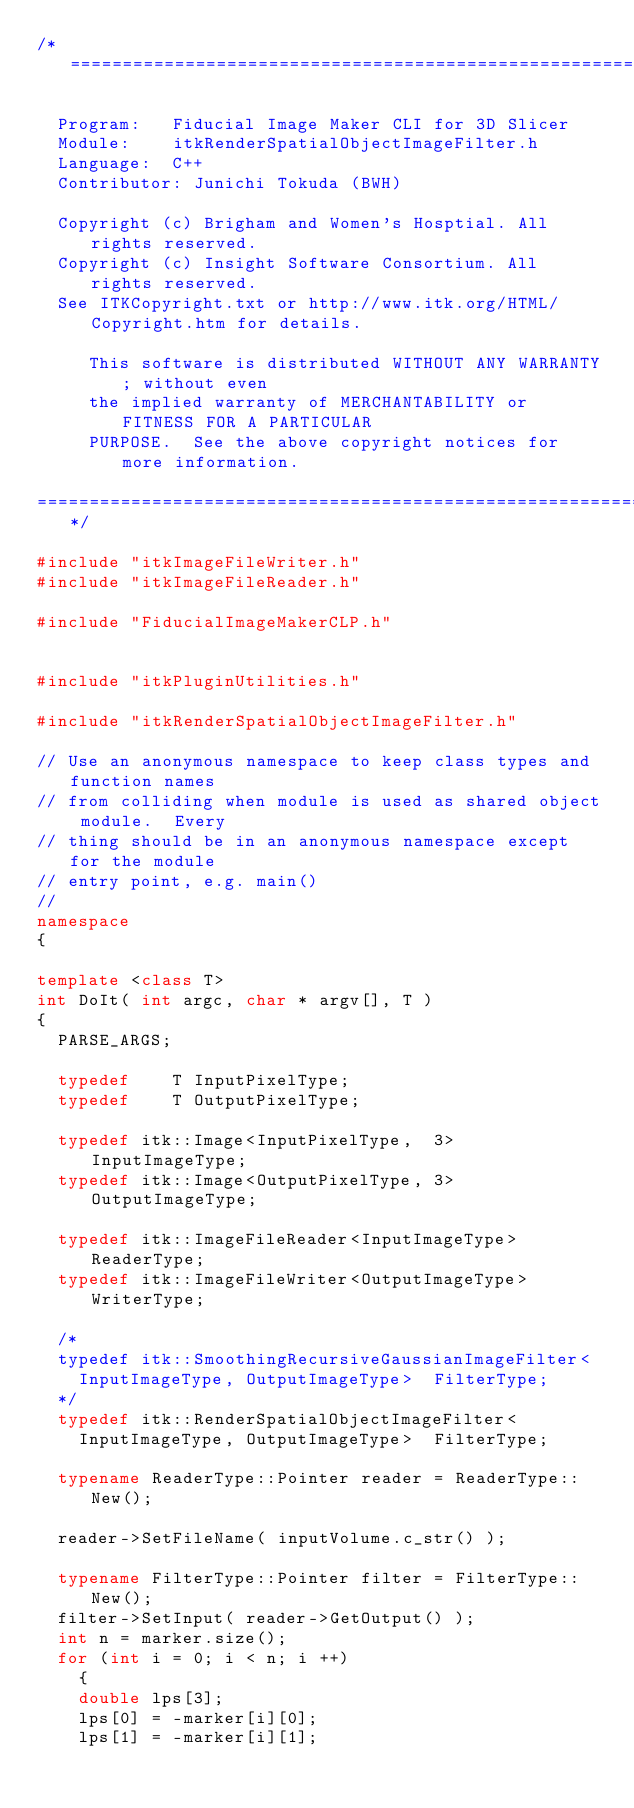Convert code to text. <code><loc_0><loc_0><loc_500><loc_500><_C++_>/*=========================================================================

  Program:   Fiducial Image Maker CLI for 3D Slicer
  Module:    itkRenderSpatialObjectImageFilter.h
  Language:  C++
  Contributor: Junichi Tokuda (BWH)

  Copyright (c) Brigham and Women's Hosptial. All rights reserved.
  Copyright (c) Insight Software Consortium. All rights reserved.
  See ITKCopyright.txt or http://www.itk.org/HTML/Copyright.htm for details.

     This software is distributed WITHOUT ANY WARRANTY; without even 
     the implied warranty of MERCHANTABILITY or FITNESS FOR A PARTICULAR 
     PURPOSE.  See the above copyright notices for more information.

=========================================================================*/

#include "itkImageFileWriter.h"
#include "itkImageFileReader.h"

#include "FiducialImageMakerCLP.h"


#include "itkPluginUtilities.h"

#include "itkRenderSpatialObjectImageFilter.h"

// Use an anonymous namespace to keep class types and function names
// from colliding when module is used as shared object module.  Every
// thing should be in an anonymous namespace except for the module
// entry point, e.g. main()
//
namespace
{

template <class T>
int DoIt( int argc, char * argv[], T )
{
  PARSE_ARGS;

  typedef    T InputPixelType;
  typedef    T OutputPixelType;

  typedef itk::Image<InputPixelType,  3> InputImageType;
  typedef itk::Image<OutputPixelType, 3> OutputImageType;

  typedef itk::ImageFileReader<InputImageType>  ReaderType;
  typedef itk::ImageFileWriter<OutputImageType> WriterType;

  /*
  typedef itk::SmoothingRecursiveGaussianImageFilter<
    InputImageType, OutputImageType>  FilterType;
  */
  typedef itk::RenderSpatialObjectImageFilter<
    InputImageType, OutputImageType>  FilterType;    

  typename ReaderType::Pointer reader = ReaderType::New();

  reader->SetFileName( inputVolume.c_str() );

  typename FilterType::Pointer filter = FilterType::New();
  filter->SetInput( reader->GetOutput() );
  int n = marker.size();
  for (int i = 0; i < n; i ++)
    {
    double lps[3];
    lps[0] = -marker[i][0];
    lps[1] = -marker[i][1];</code> 